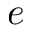Convert formula to latex. <formula><loc_0><loc_0><loc_500><loc_500>e</formula> 